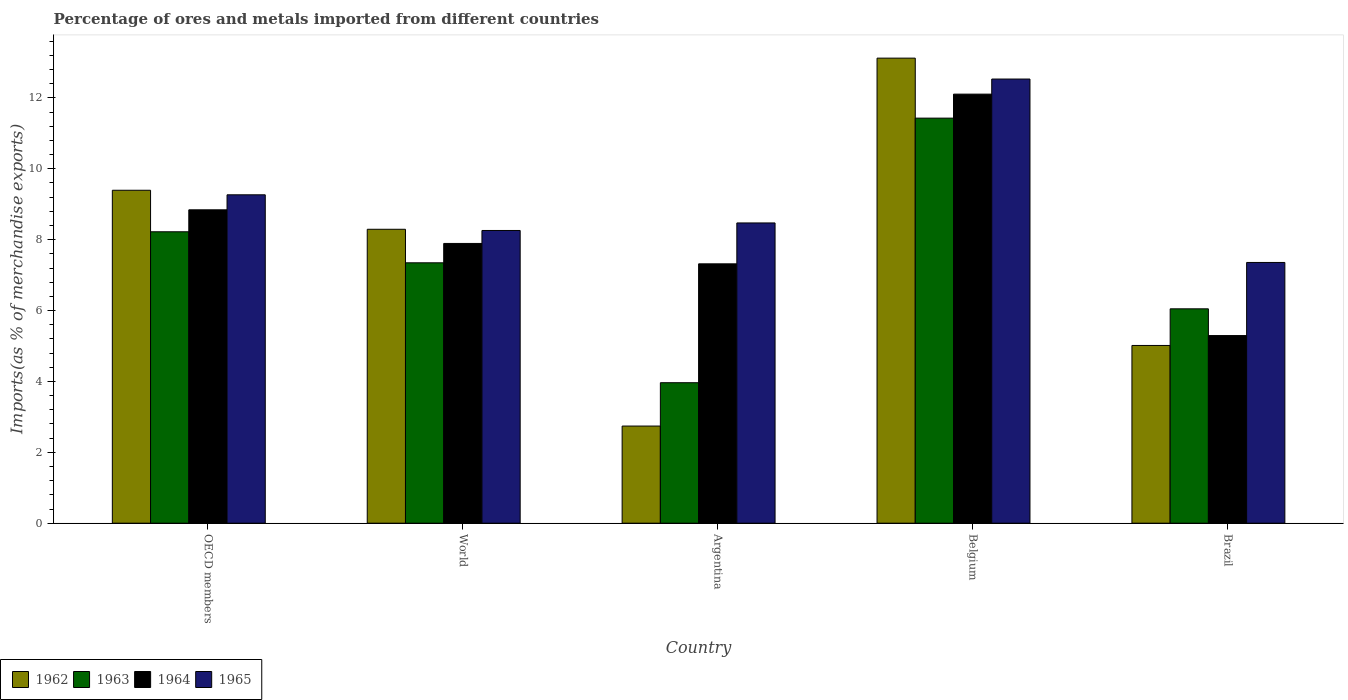How many different coloured bars are there?
Give a very brief answer. 4. How many groups of bars are there?
Your answer should be compact. 5. Are the number of bars on each tick of the X-axis equal?
Keep it short and to the point. Yes. In how many cases, is the number of bars for a given country not equal to the number of legend labels?
Your answer should be compact. 0. What is the percentage of imports to different countries in 1963 in Argentina?
Give a very brief answer. 3.96. Across all countries, what is the maximum percentage of imports to different countries in 1964?
Offer a terse response. 12.11. Across all countries, what is the minimum percentage of imports to different countries in 1964?
Provide a short and direct response. 5.29. In which country was the percentage of imports to different countries in 1964 maximum?
Your answer should be very brief. Belgium. In which country was the percentage of imports to different countries in 1962 minimum?
Your answer should be compact. Argentina. What is the total percentage of imports to different countries in 1963 in the graph?
Your answer should be very brief. 37.01. What is the difference between the percentage of imports to different countries in 1963 in Belgium and that in World?
Provide a succinct answer. 4.08. What is the difference between the percentage of imports to different countries in 1963 in Brazil and the percentage of imports to different countries in 1964 in Argentina?
Your response must be concise. -1.27. What is the average percentage of imports to different countries in 1962 per country?
Offer a very short reply. 7.71. What is the difference between the percentage of imports to different countries of/in 1964 and percentage of imports to different countries of/in 1963 in OECD members?
Give a very brief answer. 0.62. In how many countries, is the percentage of imports to different countries in 1963 greater than 1.6 %?
Provide a succinct answer. 5. What is the ratio of the percentage of imports to different countries in 1965 in Argentina to that in Brazil?
Provide a short and direct response. 1.15. Is the percentage of imports to different countries in 1965 in Brazil less than that in World?
Your response must be concise. Yes. Is the difference between the percentage of imports to different countries in 1964 in Argentina and Belgium greater than the difference between the percentage of imports to different countries in 1963 in Argentina and Belgium?
Your answer should be compact. Yes. What is the difference between the highest and the second highest percentage of imports to different countries in 1963?
Offer a terse response. -3.21. What is the difference between the highest and the lowest percentage of imports to different countries in 1963?
Your response must be concise. 7.47. In how many countries, is the percentage of imports to different countries in 1965 greater than the average percentage of imports to different countries in 1965 taken over all countries?
Your response must be concise. 2. Is the sum of the percentage of imports to different countries in 1964 in Belgium and OECD members greater than the maximum percentage of imports to different countries in 1962 across all countries?
Give a very brief answer. Yes. Is it the case that in every country, the sum of the percentage of imports to different countries in 1964 and percentage of imports to different countries in 1963 is greater than the sum of percentage of imports to different countries in 1965 and percentage of imports to different countries in 1962?
Your response must be concise. No. What does the 4th bar from the left in OECD members represents?
Provide a short and direct response. 1965. What does the 3rd bar from the right in Brazil represents?
Offer a very short reply. 1963. Does the graph contain any zero values?
Give a very brief answer. No. Where does the legend appear in the graph?
Your response must be concise. Bottom left. How are the legend labels stacked?
Ensure brevity in your answer.  Horizontal. What is the title of the graph?
Your response must be concise. Percentage of ores and metals imported from different countries. Does "2005" appear as one of the legend labels in the graph?
Offer a terse response. No. What is the label or title of the X-axis?
Give a very brief answer. Country. What is the label or title of the Y-axis?
Your response must be concise. Imports(as % of merchandise exports). What is the Imports(as % of merchandise exports) of 1962 in OECD members?
Your answer should be compact. 9.39. What is the Imports(as % of merchandise exports) of 1963 in OECD members?
Provide a short and direct response. 8.22. What is the Imports(as % of merchandise exports) of 1964 in OECD members?
Ensure brevity in your answer.  8.84. What is the Imports(as % of merchandise exports) in 1965 in OECD members?
Provide a succinct answer. 9.27. What is the Imports(as % of merchandise exports) in 1962 in World?
Keep it short and to the point. 8.29. What is the Imports(as % of merchandise exports) of 1963 in World?
Provide a short and direct response. 7.35. What is the Imports(as % of merchandise exports) in 1964 in World?
Provide a short and direct response. 7.89. What is the Imports(as % of merchandise exports) of 1965 in World?
Your answer should be very brief. 8.26. What is the Imports(as % of merchandise exports) of 1962 in Argentina?
Give a very brief answer. 2.74. What is the Imports(as % of merchandise exports) of 1963 in Argentina?
Keep it short and to the point. 3.96. What is the Imports(as % of merchandise exports) in 1964 in Argentina?
Your answer should be very brief. 7.32. What is the Imports(as % of merchandise exports) of 1965 in Argentina?
Your answer should be compact. 8.47. What is the Imports(as % of merchandise exports) in 1962 in Belgium?
Give a very brief answer. 13.12. What is the Imports(as % of merchandise exports) of 1963 in Belgium?
Your answer should be compact. 11.43. What is the Imports(as % of merchandise exports) in 1964 in Belgium?
Offer a terse response. 12.11. What is the Imports(as % of merchandise exports) in 1965 in Belgium?
Give a very brief answer. 12.53. What is the Imports(as % of merchandise exports) in 1962 in Brazil?
Make the answer very short. 5.01. What is the Imports(as % of merchandise exports) of 1963 in Brazil?
Your response must be concise. 6.05. What is the Imports(as % of merchandise exports) in 1964 in Brazil?
Ensure brevity in your answer.  5.29. What is the Imports(as % of merchandise exports) of 1965 in Brazil?
Your response must be concise. 7.36. Across all countries, what is the maximum Imports(as % of merchandise exports) of 1962?
Keep it short and to the point. 13.12. Across all countries, what is the maximum Imports(as % of merchandise exports) in 1963?
Keep it short and to the point. 11.43. Across all countries, what is the maximum Imports(as % of merchandise exports) of 1964?
Your answer should be very brief. 12.11. Across all countries, what is the maximum Imports(as % of merchandise exports) in 1965?
Ensure brevity in your answer.  12.53. Across all countries, what is the minimum Imports(as % of merchandise exports) of 1962?
Offer a terse response. 2.74. Across all countries, what is the minimum Imports(as % of merchandise exports) of 1963?
Your answer should be very brief. 3.96. Across all countries, what is the minimum Imports(as % of merchandise exports) in 1964?
Your answer should be compact. 5.29. Across all countries, what is the minimum Imports(as % of merchandise exports) of 1965?
Give a very brief answer. 7.36. What is the total Imports(as % of merchandise exports) of 1962 in the graph?
Keep it short and to the point. 38.56. What is the total Imports(as % of merchandise exports) in 1963 in the graph?
Give a very brief answer. 37.01. What is the total Imports(as % of merchandise exports) in 1964 in the graph?
Ensure brevity in your answer.  41.45. What is the total Imports(as % of merchandise exports) in 1965 in the graph?
Your response must be concise. 45.89. What is the difference between the Imports(as % of merchandise exports) in 1962 in OECD members and that in World?
Make the answer very short. 1.1. What is the difference between the Imports(as % of merchandise exports) of 1963 in OECD members and that in World?
Offer a very short reply. 0.88. What is the difference between the Imports(as % of merchandise exports) in 1964 in OECD members and that in World?
Provide a succinct answer. 0.95. What is the difference between the Imports(as % of merchandise exports) of 1965 in OECD members and that in World?
Offer a very short reply. 1.01. What is the difference between the Imports(as % of merchandise exports) in 1962 in OECD members and that in Argentina?
Your answer should be very brief. 6.65. What is the difference between the Imports(as % of merchandise exports) in 1963 in OECD members and that in Argentina?
Make the answer very short. 4.26. What is the difference between the Imports(as % of merchandise exports) in 1964 in OECD members and that in Argentina?
Keep it short and to the point. 1.52. What is the difference between the Imports(as % of merchandise exports) in 1965 in OECD members and that in Argentina?
Ensure brevity in your answer.  0.79. What is the difference between the Imports(as % of merchandise exports) of 1962 in OECD members and that in Belgium?
Offer a very short reply. -3.73. What is the difference between the Imports(as % of merchandise exports) in 1963 in OECD members and that in Belgium?
Offer a very short reply. -3.21. What is the difference between the Imports(as % of merchandise exports) in 1964 in OECD members and that in Belgium?
Provide a short and direct response. -3.26. What is the difference between the Imports(as % of merchandise exports) of 1965 in OECD members and that in Belgium?
Provide a short and direct response. -3.27. What is the difference between the Imports(as % of merchandise exports) of 1962 in OECD members and that in Brazil?
Your answer should be compact. 4.38. What is the difference between the Imports(as % of merchandise exports) in 1963 in OECD members and that in Brazil?
Your answer should be compact. 2.17. What is the difference between the Imports(as % of merchandise exports) in 1964 in OECD members and that in Brazil?
Your answer should be compact. 3.55. What is the difference between the Imports(as % of merchandise exports) in 1965 in OECD members and that in Brazil?
Provide a succinct answer. 1.91. What is the difference between the Imports(as % of merchandise exports) in 1962 in World and that in Argentina?
Your answer should be very brief. 5.55. What is the difference between the Imports(as % of merchandise exports) of 1963 in World and that in Argentina?
Keep it short and to the point. 3.38. What is the difference between the Imports(as % of merchandise exports) in 1964 in World and that in Argentina?
Provide a succinct answer. 0.58. What is the difference between the Imports(as % of merchandise exports) of 1965 in World and that in Argentina?
Ensure brevity in your answer.  -0.21. What is the difference between the Imports(as % of merchandise exports) of 1962 in World and that in Belgium?
Your response must be concise. -4.83. What is the difference between the Imports(as % of merchandise exports) in 1963 in World and that in Belgium?
Your answer should be very brief. -4.08. What is the difference between the Imports(as % of merchandise exports) in 1964 in World and that in Belgium?
Ensure brevity in your answer.  -4.21. What is the difference between the Imports(as % of merchandise exports) in 1965 in World and that in Belgium?
Ensure brevity in your answer.  -4.27. What is the difference between the Imports(as % of merchandise exports) in 1962 in World and that in Brazil?
Offer a terse response. 3.28. What is the difference between the Imports(as % of merchandise exports) in 1963 in World and that in Brazil?
Give a very brief answer. 1.3. What is the difference between the Imports(as % of merchandise exports) of 1964 in World and that in Brazil?
Your answer should be very brief. 2.6. What is the difference between the Imports(as % of merchandise exports) in 1965 in World and that in Brazil?
Your response must be concise. 0.9. What is the difference between the Imports(as % of merchandise exports) in 1962 in Argentina and that in Belgium?
Give a very brief answer. -10.38. What is the difference between the Imports(as % of merchandise exports) in 1963 in Argentina and that in Belgium?
Give a very brief answer. -7.46. What is the difference between the Imports(as % of merchandise exports) in 1964 in Argentina and that in Belgium?
Ensure brevity in your answer.  -4.79. What is the difference between the Imports(as % of merchandise exports) in 1965 in Argentina and that in Belgium?
Ensure brevity in your answer.  -4.06. What is the difference between the Imports(as % of merchandise exports) of 1962 in Argentina and that in Brazil?
Give a very brief answer. -2.27. What is the difference between the Imports(as % of merchandise exports) in 1963 in Argentina and that in Brazil?
Keep it short and to the point. -2.08. What is the difference between the Imports(as % of merchandise exports) in 1964 in Argentina and that in Brazil?
Give a very brief answer. 2.02. What is the difference between the Imports(as % of merchandise exports) of 1965 in Argentina and that in Brazil?
Your response must be concise. 1.12. What is the difference between the Imports(as % of merchandise exports) of 1962 in Belgium and that in Brazil?
Your answer should be very brief. 8.11. What is the difference between the Imports(as % of merchandise exports) in 1963 in Belgium and that in Brazil?
Provide a succinct answer. 5.38. What is the difference between the Imports(as % of merchandise exports) in 1964 in Belgium and that in Brazil?
Ensure brevity in your answer.  6.81. What is the difference between the Imports(as % of merchandise exports) of 1965 in Belgium and that in Brazil?
Your response must be concise. 5.18. What is the difference between the Imports(as % of merchandise exports) of 1962 in OECD members and the Imports(as % of merchandise exports) of 1963 in World?
Your answer should be compact. 2.05. What is the difference between the Imports(as % of merchandise exports) of 1962 in OECD members and the Imports(as % of merchandise exports) of 1964 in World?
Your answer should be compact. 1.5. What is the difference between the Imports(as % of merchandise exports) of 1962 in OECD members and the Imports(as % of merchandise exports) of 1965 in World?
Ensure brevity in your answer.  1.13. What is the difference between the Imports(as % of merchandise exports) of 1963 in OECD members and the Imports(as % of merchandise exports) of 1964 in World?
Make the answer very short. 0.33. What is the difference between the Imports(as % of merchandise exports) of 1963 in OECD members and the Imports(as % of merchandise exports) of 1965 in World?
Give a very brief answer. -0.04. What is the difference between the Imports(as % of merchandise exports) in 1964 in OECD members and the Imports(as % of merchandise exports) in 1965 in World?
Your response must be concise. 0.58. What is the difference between the Imports(as % of merchandise exports) in 1962 in OECD members and the Imports(as % of merchandise exports) in 1963 in Argentina?
Provide a succinct answer. 5.43. What is the difference between the Imports(as % of merchandise exports) in 1962 in OECD members and the Imports(as % of merchandise exports) in 1964 in Argentina?
Make the answer very short. 2.08. What is the difference between the Imports(as % of merchandise exports) in 1962 in OECD members and the Imports(as % of merchandise exports) in 1965 in Argentina?
Ensure brevity in your answer.  0.92. What is the difference between the Imports(as % of merchandise exports) in 1963 in OECD members and the Imports(as % of merchandise exports) in 1964 in Argentina?
Offer a very short reply. 0.9. What is the difference between the Imports(as % of merchandise exports) in 1963 in OECD members and the Imports(as % of merchandise exports) in 1965 in Argentina?
Give a very brief answer. -0.25. What is the difference between the Imports(as % of merchandise exports) of 1964 in OECD members and the Imports(as % of merchandise exports) of 1965 in Argentina?
Your answer should be compact. 0.37. What is the difference between the Imports(as % of merchandise exports) of 1962 in OECD members and the Imports(as % of merchandise exports) of 1963 in Belgium?
Give a very brief answer. -2.04. What is the difference between the Imports(as % of merchandise exports) of 1962 in OECD members and the Imports(as % of merchandise exports) of 1964 in Belgium?
Offer a terse response. -2.71. What is the difference between the Imports(as % of merchandise exports) in 1962 in OECD members and the Imports(as % of merchandise exports) in 1965 in Belgium?
Offer a very short reply. -3.14. What is the difference between the Imports(as % of merchandise exports) in 1963 in OECD members and the Imports(as % of merchandise exports) in 1964 in Belgium?
Ensure brevity in your answer.  -3.88. What is the difference between the Imports(as % of merchandise exports) of 1963 in OECD members and the Imports(as % of merchandise exports) of 1965 in Belgium?
Offer a very short reply. -4.31. What is the difference between the Imports(as % of merchandise exports) in 1964 in OECD members and the Imports(as % of merchandise exports) in 1965 in Belgium?
Your response must be concise. -3.69. What is the difference between the Imports(as % of merchandise exports) of 1962 in OECD members and the Imports(as % of merchandise exports) of 1963 in Brazil?
Offer a very short reply. 3.35. What is the difference between the Imports(as % of merchandise exports) of 1962 in OECD members and the Imports(as % of merchandise exports) of 1964 in Brazil?
Offer a terse response. 4.1. What is the difference between the Imports(as % of merchandise exports) in 1962 in OECD members and the Imports(as % of merchandise exports) in 1965 in Brazil?
Your answer should be very brief. 2.04. What is the difference between the Imports(as % of merchandise exports) of 1963 in OECD members and the Imports(as % of merchandise exports) of 1964 in Brazil?
Make the answer very short. 2.93. What is the difference between the Imports(as % of merchandise exports) of 1963 in OECD members and the Imports(as % of merchandise exports) of 1965 in Brazil?
Give a very brief answer. 0.87. What is the difference between the Imports(as % of merchandise exports) in 1964 in OECD members and the Imports(as % of merchandise exports) in 1965 in Brazil?
Provide a short and direct response. 1.49. What is the difference between the Imports(as % of merchandise exports) of 1962 in World and the Imports(as % of merchandise exports) of 1963 in Argentina?
Provide a short and direct response. 4.33. What is the difference between the Imports(as % of merchandise exports) of 1962 in World and the Imports(as % of merchandise exports) of 1964 in Argentina?
Keep it short and to the point. 0.98. What is the difference between the Imports(as % of merchandise exports) of 1962 in World and the Imports(as % of merchandise exports) of 1965 in Argentina?
Give a very brief answer. -0.18. What is the difference between the Imports(as % of merchandise exports) in 1963 in World and the Imports(as % of merchandise exports) in 1964 in Argentina?
Offer a very short reply. 0.03. What is the difference between the Imports(as % of merchandise exports) in 1963 in World and the Imports(as % of merchandise exports) in 1965 in Argentina?
Provide a succinct answer. -1.12. What is the difference between the Imports(as % of merchandise exports) of 1964 in World and the Imports(as % of merchandise exports) of 1965 in Argentina?
Make the answer very short. -0.58. What is the difference between the Imports(as % of merchandise exports) of 1962 in World and the Imports(as % of merchandise exports) of 1963 in Belgium?
Offer a terse response. -3.14. What is the difference between the Imports(as % of merchandise exports) in 1962 in World and the Imports(as % of merchandise exports) in 1964 in Belgium?
Your response must be concise. -3.81. What is the difference between the Imports(as % of merchandise exports) of 1962 in World and the Imports(as % of merchandise exports) of 1965 in Belgium?
Your answer should be compact. -4.24. What is the difference between the Imports(as % of merchandise exports) of 1963 in World and the Imports(as % of merchandise exports) of 1964 in Belgium?
Your answer should be compact. -4.76. What is the difference between the Imports(as % of merchandise exports) of 1963 in World and the Imports(as % of merchandise exports) of 1965 in Belgium?
Provide a succinct answer. -5.18. What is the difference between the Imports(as % of merchandise exports) of 1964 in World and the Imports(as % of merchandise exports) of 1965 in Belgium?
Offer a very short reply. -4.64. What is the difference between the Imports(as % of merchandise exports) in 1962 in World and the Imports(as % of merchandise exports) in 1963 in Brazil?
Offer a terse response. 2.24. What is the difference between the Imports(as % of merchandise exports) in 1962 in World and the Imports(as % of merchandise exports) in 1964 in Brazil?
Provide a succinct answer. 3. What is the difference between the Imports(as % of merchandise exports) of 1962 in World and the Imports(as % of merchandise exports) of 1965 in Brazil?
Give a very brief answer. 0.94. What is the difference between the Imports(as % of merchandise exports) of 1963 in World and the Imports(as % of merchandise exports) of 1964 in Brazil?
Offer a terse response. 2.05. What is the difference between the Imports(as % of merchandise exports) in 1963 in World and the Imports(as % of merchandise exports) in 1965 in Brazil?
Offer a terse response. -0.01. What is the difference between the Imports(as % of merchandise exports) in 1964 in World and the Imports(as % of merchandise exports) in 1965 in Brazil?
Your answer should be compact. 0.54. What is the difference between the Imports(as % of merchandise exports) in 1962 in Argentina and the Imports(as % of merchandise exports) in 1963 in Belgium?
Offer a terse response. -8.69. What is the difference between the Imports(as % of merchandise exports) in 1962 in Argentina and the Imports(as % of merchandise exports) in 1964 in Belgium?
Provide a short and direct response. -9.37. What is the difference between the Imports(as % of merchandise exports) in 1962 in Argentina and the Imports(as % of merchandise exports) in 1965 in Belgium?
Keep it short and to the point. -9.79. What is the difference between the Imports(as % of merchandise exports) in 1963 in Argentina and the Imports(as % of merchandise exports) in 1964 in Belgium?
Your answer should be very brief. -8.14. What is the difference between the Imports(as % of merchandise exports) of 1963 in Argentina and the Imports(as % of merchandise exports) of 1965 in Belgium?
Offer a very short reply. -8.57. What is the difference between the Imports(as % of merchandise exports) in 1964 in Argentina and the Imports(as % of merchandise exports) in 1965 in Belgium?
Give a very brief answer. -5.21. What is the difference between the Imports(as % of merchandise exports) of 1962 in Argentina and the Imports(as % of merchandise exports) of 1963 in Brazil?
Provide a succinct answer. -3.31. What is the difference between the Imports(as % of merchandise exports) in 1962 in Argentina and the Imports(as % of merchandise exports) in 1964 in Brazil?
Provide a succinct answer. -2.55. What is the difference between the Imports(as % of merchandise exports) in 1962 in Argentina and the Imports(as % of merchandise exports) in 1965 in Brazil?
Keep it short and to the point. -4.62. What is the difference between the Imports(as % of merchandise exports) of 1963 in Argentina and the Imports(as % of merchandise exports) of 1964 in Brazil?
Ensure brevity in your answer.  -1.33. What is the difference between the Imports(as % of merchandise exports) of 1963 in Argentina and the Imports(as % of merchandise exports) of 1965 in Brazil?
Make the answer very short. -3.39. What is the difference between the Imports(as % of merchandise exports) of 1964 in Argentina and the Imports(as % of merchandise exports) of 1965 in Brazil?
Give a very brief answer. -0.04. What is the difference between the Imports(as % of merchandise exports) in 1962 in Belgium and the Imports(as % of merchandise exports) in 1963 in Brazil?
Your response must be concise. 7.07. What is the difference between the Imports(as % of merchandise exports) in 1962 in Belgium and the Imports(as % of merchandise exports) in 1964 in Brazil?
Ensure brevity in your answer.  7.83. What is the difference between the Imports(as % of merchandise exports) of 1962 in Belgium and the Imports(as % of merchandise exports) of 1965 in Brazil?
Your answer should be compact. 5.77. What is the difference between the Imports(as % of merchandise exports) of 1963 in Belgium and the Imports(as % of merchandise exports) of 1964 in Brazil?
Keep it short and to the point. 6.14. What is the difference between the Imports(as % of merchandise exports) of 1963 in Belgium and the Imports(as % of merchandise exports) of 1965 in Brazil?
Ensure brevity in your answer.  4.07. What is the difference between the Imports(as % of merchandise exports) of 1964 in Belgium and the Imports(as % of merchandise exports) of 1965 in Brazil?
Keep it short and to the point. 4.75. What is the average Imports(as % of merchandise exports) in 1962 per country?
Keep it short and to the point. 7.71. What is the average Imports(as % of merchandise exports) of 1963 per country?
Your answer should be compact. 7.4. What is the average Imports(as % of merchandise exports) of 1964 per country?
Your answer should be compact. 8.29. What is the average Imports(as % of merchandise exports) of 1965 per country?
Offer a very short reply. 9.18. What is the difference between the Imports(as % of merchandise exports) in 1962 and Imports(as % of merchandise exports) in 1963 in OECD members?
Provide a succinct answer. 1.17. What is the difference between the Imports(as % of merchandise exports) of 1962 and Imports(as % of merchandise exports) of 1964 in OECD members?
Offer a terse response. 0.55. What is the difference between the Imports(as % of merchandise exports) in 1962 and Imports(as % of merchandise exports) in 1965 in OECD members?
Make the answer very short. 0.13. What is the difference between the Imports(as % of merchandise exports) in 1963 and Imports(as % of merchandise exports) in 1964 in OECD members?
Provide a short and direct response. -0.62. What is the difference between the Imports(as % of merchandise exports) of 1963 and Imports(as % of merchandise exports) of 1965 in OECD members?
Your answer should be compact. -1.04. What is the difference between the Imports(as % of merchandise exports) of 1964 and Imports(as % of merchandise exports) of 1965 in OECD members?
Give a very brief answer. -0.42. What is the difference between the Imports(as % of merchandise exports) of 1962 and Imports(as % of merchandise exports) of 1963 in World?
Offer a terse response. 0.95. What is the difference between the Imports(as % of merchandise exports) in 1962 and Imports(as % of merchandise exports) in 1964 in World?
Offer a very short reply. 0.4. What is the difference between the Imports(as % of merchandise exports) in 1962 and Imports(as % of merchandise exports) in 1965 in World?
Your response must be concise. 0.03. What is the difference between the Imports(as % of merchandise exports) in 1963 and Imports(as % of merchandise exports) in 1964 in World?
Offer a terse response. -0.55. What is the difference between the Imports(as % of merchandise exports) of 1963 and Imports(as % of merchandise exports) of 1965 in World?
Offer a terse response. -0.91. What is the difference between the Imports(as % of merchandise exports) of 1964 and Imports(as % of merchandise exports) of 1965 in World?
Offer a very short reply. -0.37. What is the difference between the Imports(as % of merchandise exports) of 1962 and Imports(as % of merchandise exports) of 1963 in Argentina?
Make the answer very short. -1.22. What is the difference between the Imports(as % of merchandise exports) in 1962 and Imports(as % of merchandise exports) in 1964 in Argentina?
Provide a succinct answer. -4.58. What is the difference between the Imports(as % of merchandise exports) of 1962 and Imports(as % of merchandise exports) of 1965 in Argentina?
Keep it short and to the point. -5.73. What is the difference between the Imports(as % of merchandise exports) of 1963 and Imports(as % of merchandise exports) of 1964 in Argentina?
Ensure brevity in your answer.  -3.35. What is the difference between the Imports(as % of merchandise exports) in 1963 and Imports(as % of merchandise exports) in 1965 in Argentina?
Give a very brief answer. -4.51. What is the difference between the Imports(as % of merchandise exports) in 1964 and Imports(as % of merchandise exports) in 1965 in Argentina?
Make the answer very short. -1.15. What is the difference between the Imports(as % of merchandise exports) of 1962 and Imports(as % of merchandise exports) of 1963 in Belgium?
Offer a terse response. 1.69. What is the difference between the Imports(as % of merchandise exports) of 1962 and Imports(as % of merchandise exports) of 1965 in Belgium?
Your answer should be compact. 0.59. What is the difference between the Imports(as % of merchandise exports) in 1963 and Imports(as % of merchandise exports) in 1964 in Belgium?
Offer a very short reply. -0.68. What is the difference between the Imports(as % of merchandise exports) in 1963 and Imports(as % of merchandise exports) in 1965 in Belgium?
Your answer should be very brief. -1.1. What is the difference between the Imports(as % of merchandise exports) of 1964 and Imports(as % of merchandise exports) of 1965 in Belgium?
Give a very brief answer. -0.43. What is the difference between the Imports(as % of merchandise exports) in 1962 and Imports(as % of merchandise exports) in 1963 in Brazil?
Offer a terse response. -1.03. What is the difference between the Imports(as % of merchandise exports) in 1962 and Imports(as % of merchandise exports) in 1964 in Brazil?
Make the answer very short. -0.28. What is the difference between the Imports(as % of merchandise exports) of 1962 and Imports(as % of merchandise exports) of 1965 in Brazil?
Your response must be concise. -2.34. What is the difference between the Imports(as % of merchandise exports) of 1963 and Imports(as % of merchandise exports) of 1964 in Brazil?
Provide a succinct answer. 0.75. What is the difference between the Imports(as % of merchandise exports) of 1963 and Imports(as % of merchandise exports) of 1965 in Brazil?
Offer a terse response. -1.31. What is the difference between the Imports(as % of merchandise exports) of 1964 and Imports(as % of merchandise exports) of 1965 in Brazil?
Your answer should be compact. -2.06. What is the ratio of the Imports(as % of merchandise exports) in 1962 in OECD members to that in World?
Provide a succinct answer. 1.13. What is the ratio of the Imports(as % of merchandise exports) in 1963 in OECD members to that in World?
Provide a succinct answer. 1.12. What is the ratio of the Imports(as % of merchandise exports) of 1964 in OECD members to that in World?
Provide a short and direct response. 1.12. What is the ratio of the Imports(as % of merchandise exports) in 1965 in OECD members to that in World?
Offer a terse response. 1.12. What is the ratio of the Imports(as % of merchandise exports) of 1962 in OECD members to that in Argentina?
Keep it short and to the point. 3.43. What is the ratio of the Imports(as % of merchandise exports) of 1963 in OECD members to that in Argentina?
Your response must be concise. 2.07. What is the ratio of the Imports(as % of merchandise exports) in 1964 in OECD members to that in Argentina?
Your response must be concise. 1.21. What is the ratio of the Imports(as % of merchandise exports) in 1965 in OECD members to that in Argentina?
Your answer should be very brief. 1.09. What is the ratio of the Imports(as % of merchandise exports) of 1962 in OECD members to that in Belgium?
Offer a very short reply. 0.72. What is the ratio of the Imports(as % of merchandise exports) of 1963 in OECD members to that in Belgium?
Ensure brevity in your answer.  0.72. What is the ratio of the Imports(as % of merchandise exports) in 1964 in OECD members to that in Belgium?
Offer a terse response. 0.73. What is the ratio of the Imports(as % of merchandise exports) of 1965 in OECD members to that in Belgium?
Keep it short and to the point. 0.74. What is the ratio of the Imports(as % of merchandise exports) in 1962 in OECD members to that in Brazil?
Keep it short and to the point. 1.87. What is the ratio of the Imports(as % of merchandise exports) of 1963 in OECD members to that in Brazil?
Provide a succinct answer. 1.36. What is the ratio of the Imports(as % of merchandise exports) in 1964 in OECD members to that in Brazil?
Give a very brief answer. 1.67. What is the ratio of the Imports(as % of merchandise exports) in 1965 in OECD members to that in Brazil?
Provide a short and direct response. 1.26. What is the ratio of the Imports(as % of merchandise exports) in 1962 in World to that in Argentina?
Provide a short and direct response. 3.03. What is the ratio of the Imports(as % of merchandise exports) in 1963 in World to that in Argentina?
Provide a succinct answer. 1.85. What is the ratio of the Imports(as % of merchandise exports) in 1964 in World to that in Argentina?
Your answer should be very brief. 1.08. What is the ratio of the Imports(as % of merchandise exports) of 1965 in World to that in Argentina?
Give a very brief answer. 0.97. What is the ratio of the Imports(as % of merchandise exports) in 1962 in World to that in Belgium?
Offer a terse response. 0.63. What is the ratio of the Imports(as % of merchandise exports) in 1963 in World to that in Belgium?
Give a very brief answer. 0.64. What is the ratio of the Imports(as % of merchandise exports) of 1964 in World to that in Belgium?
Offer a terse response. 0.65. What is the ratio of the Imports(as % of merchandise exports) in 1965 in World to that in Belgium?
Provide a succinct answer. 0.66. What is the ratio of the Imports(as % of merchandise exports) in 1962 in World to that in Brazil?
Keep it short and to the point. 1.65. What is the ratio of the Imports(as % of merchandise exports) of 1963 in World to that in Brazil?
Your answer should be very brief. 1.21. What is the ratio of the Imports(as % of merchandise exports) of 1964 in World to that in Brazil?
Keep it short and to the point. 1.49. What is the ratio of the Imports(as % of merchandise exports) of 1965 in World to that in Brazil?
Your answer should be compact. 1.12. What is the ratio of the Imports(as % of merchandise exports) of 1962 in Argentina to that in Belgium?
Your answer should be very brief. 0.21. What is the ratio of the Imports(as % of merchandise exports) of 1963 in Argentina to that in Belgium?
Your answer should be very brief. 0.35. What is the ratio of the Imports(as % of merchandise exports) of 1964 in Argentina to that in Belgium?
Your response must be concise. 0.6. What is the ratio of the Imports(as % of merchandise exports) in 1965 in Argentina to that in Belgium?
Provide a succinct answer. 0.68. What is the ratio of the Imports(as % of merchandise exports) of 1962 in Argentina to that in Brazil?
Offer a terse response. 0.55. What is the ratio of the Imports(as % of merchandise exports) of 1963 in Argentina to that in Brazil?
Your answer should be very brief. 0.66. What is the ratio of the Imports(as % of merchandise exports) of 1964 in Argentina to that in Brazil?
Offer a terse response. 1.38. What is the ratio of the Imports(as % of merchandise exports) in 1965 in Argentina to that in Brazil?
Your answer should be compact. 1.15. What is the ratio of the Imports(as % of merchandise exports) of 1962 in Belgium to that in Brazil?
Keep it short and to the point. 2.62. What is the ratio of the Imports(as % of merchandise exports) in 1963 in Belgium to that in Brazil?
Provide a succinct answer. 1.89. What is the ratio of the Imports(as % of merchandise exports) in 1964 in Belgium to that in Brazil?
Provide a succinct answer. 2.29. What is the ratio of the Imports(as % of merchandise exports) of 1965 in Belgium to that in Brazil?
Give a very brief answer. 1.7. What is the difference between the highest and the second highest Imports(as % of merchandise exports) in 1962?
Offer a terse response. 3.73. What is the difference between the highest and the second highest Imports(as % of merchandise exports) of 1963?
Give a very brief answer. 3.21. What is the difference between the highest and the second highest Imports(as % of merchandise exports) of 1964?
Your response must be concise. 3.26. What is the difference between the highest and the second highest Imports(as % of merchandise exports) of 1965?
Your response must be concise. 3.27. What is the difference between the highest and the lowest Imports(as % of merchandise exports) of 1962?
Make the answer very short. 10.38. What is the difference between the highest and the lowest Imports(as % of merchandise exports) in 1963?
Your answer should be compact. 7.46. What is the difference between the highest and the lowest Imports(as % of merchandise exports) of 1964?
Provide a succinct answer. 6.81. What is the difference between the highest and the lowest Imports(as % of merchandise exports) in 1965?
Give a very brief answer. 5.18. 